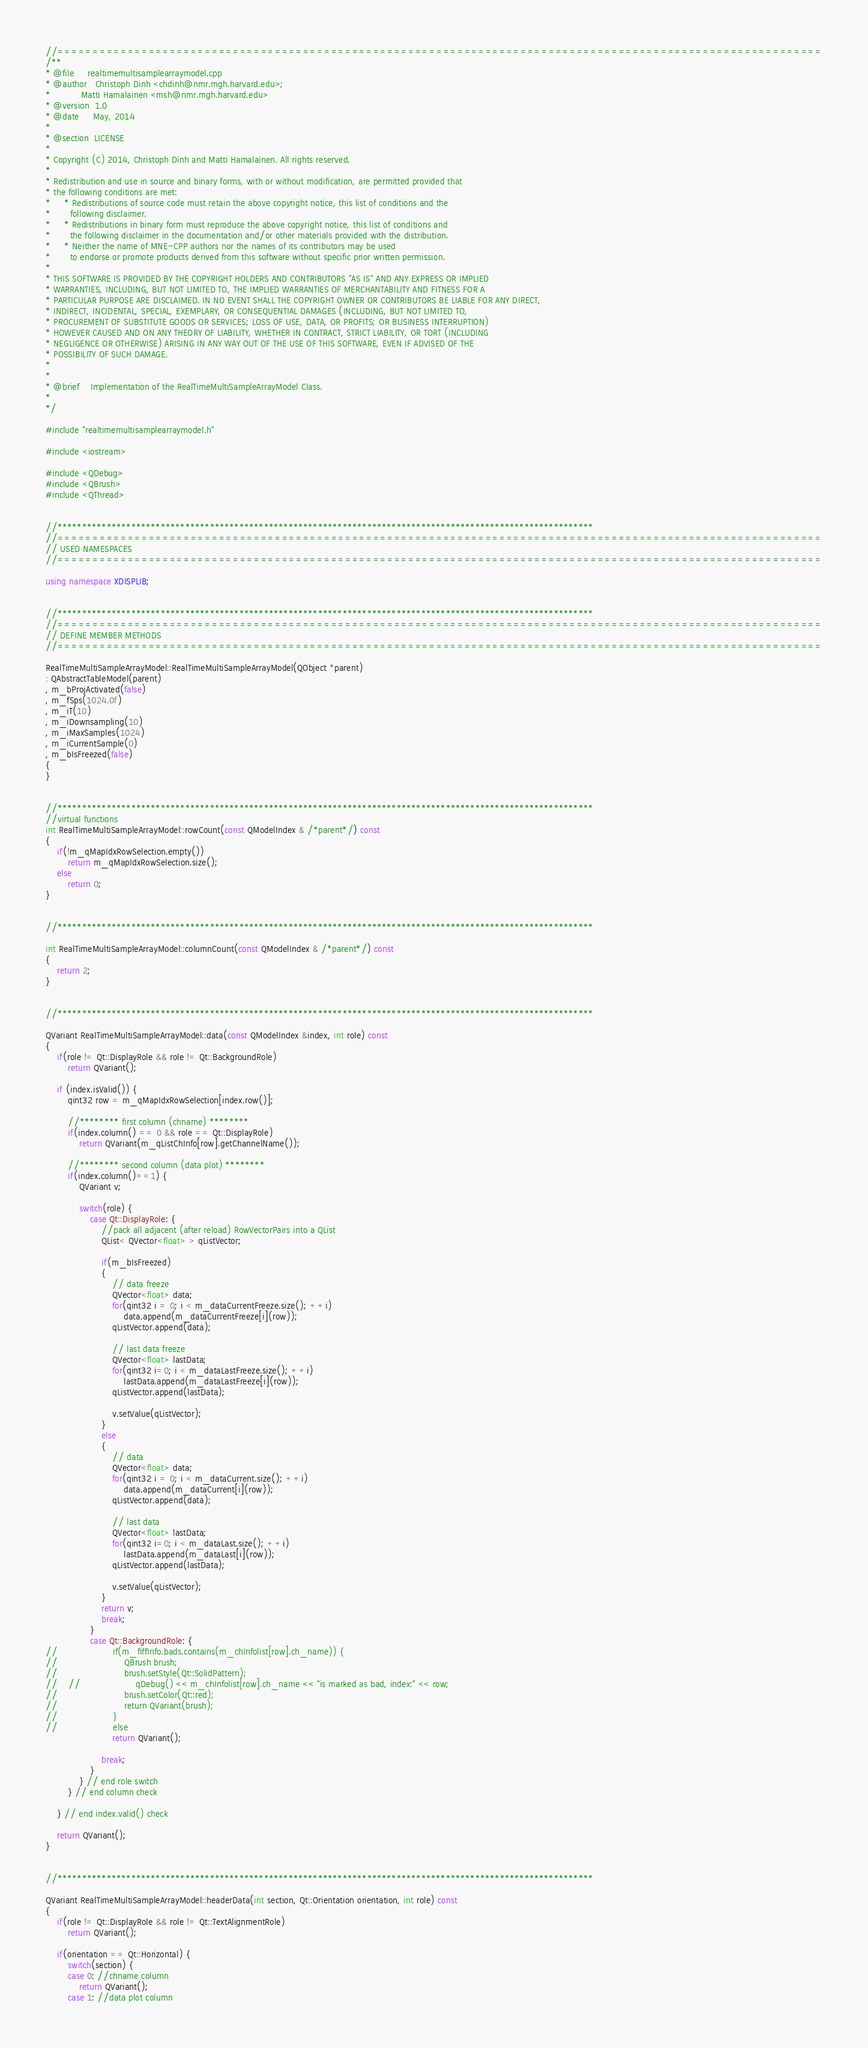Convert code to text. <code><loc_0><loc_0><loc_500><loc_500><_C++_>//=============================================================================================================
/**
* @file     realtimemultisamplearraymodel.cpp
* @author   Christoph Dinh <chdinh@nmr.mgh.harvard.edu>;
*           Matti Hamalainen <msh@nmr.mgh.harvard.edu>
* @version  1.0
* @date     May, 2014
*
* @section  LICENSE
*
* Copyright (C) 2014, Christoph Dinh and Matti Hamalainen. All rights reserved.
*
* Redistribution and use in source and binary forms, with or without modification, are permitted provided that
* the following conditions are met:
*     * Redistributions of source code must retain the above copyright notice, this list of conditions and the
*       following disclaimer.
*     * Redistributions in binary form must reproduce the above copyright notice, this list of conditions and
*       the following disclaimer in the documentation and/or other materials provided with the distribution.
*     * Neither the name of MNE-CPP authors nor the names of its contributors may be used
*       to endorse or promote products derived from this software without specific prior written permission.
*
* THIS SOFTWARE IS PROVIDED BY THE COPYRIGHT HOLDERS AND CONTRIBUTORS "AS IS" AND ANY EXPRESS OR IMPLIED
* WARRANTIES, INCLUDING, BUT NOT LIMITED TO, THE IMPLIED WARRANTIES OF MERCHANTABILITY AND FITNESS FOR A
* PARTICULAR PURPOSE ARE DISCLAIMED. IN NO EVENT SHALL THE COPYRIGHT OWNER OR CONTRIBUTORS BE LIABLE FOR ANY DIRECT,
* INDIRECT, INCIDENTAL, SPECIAL, EXEMPLARY, OR CONSEQUENTIAL DAMAGES (INCLUDING, BUT NOT LIMITED TO,
* PROCUREMENT OF SUBSTITUTE GOODS OR SERVICES; LOSS OF USE, DATA, OR PROFITS; OR BUSINESS INTERRUPTION)
* HOWEVER CAUSED AND ON ANY THEORY OF LIABILITY, WHETHER IN CONTRACT, STRICT LIABILITY, OR TORT (INCLUDING
* NEGLIGENCE OR OTHERWISE) ARISING IN ANY WAY OUT OF THE USE OF THIS SOFTWARE, EVEN IF ADVISED OF THE
* POSSIBILITY OF SUCH DAMAGE.
*
*
* @brief    Implementation of the RealTimeMultiSampleArrayModel Class.
*
*/

#include "realtimemultisamplearraymodel.h"

#include <iostream>

#include <QDebug>
#include <QBrush>
#include <QThread>


//*************************************************************************************************************
//=============================================================================================================
// USED NAMESPACES
//=============================================================================================================

using namespace XDISPLIB;


//*************************************************************************************************************
//=============================================================================================================
// DEFINE MEMBER METHODS
//=============================================================================================================

RealTimeMultiSampleArrayModel::RealTimeMultiSampleArrayModel(QObject *parent)
: QAbstractTableModel(parent)
, m_bProjActivated(false)
, m_fSps(1024.0f)
, m_iT(10)
, m_iDownsampling(10)
, m_iMaxSamples(1024)
, m_iCurrentSample(0)
, m_bIsFreezed(false)
{
}


//*************************************************************************************************************
//virtual functions
int RealTimeMultiSampleArrayModel::rowCount(const QModelIndex & /*parent*/) const
{
    if(!m_qMapIdxRowSelection.empty())
        return m_qMapIdxRowSelection.size();
    else
        return 0;
}


//*************************************************************************************************************

int RealTimeMultiSampleArrayModel::columnCount(const QModelIndex & /*parent*/) const
{
    return 2;
}


//*************************************************************************************************************

QVariant RealTimeMultiSampleArrayModel::data(const QModelIndex &index, int role) const
{
    if(role != Qt::DisplayRole && role != Qt::BackgroundRole)
        return QVariant();

    if (index.isValid()) {
        qint32 row = m_qMapIdxRowSelection[index.row()];

        //******** first column (chname) ********
        if(index.column() == 0 && role == Qt::DisplayRole)
            return QVariant(m_qListChInfo[row].getChannelName());

        //******** second column (data plot) ********
        if(index.column()==1) {
            QVariant v;

            switch(role) {
                case Qt::DisplayRole: {
                    //pack all adjacent (after reload) RowVectorPairs into a QList
                    QList< QVector<float> > qListVector;

                    if(m_bIsFreezed)
                    {
                        // data freeze
                        QVector<float> data;
                        for(qint32 i = 0; i < m_dataCurrentFreeze.size(); ++i)
                            data.append(m_dataCurrentFreeze[i](row));
                        qListVector.append(data);

                        // last data freeze
                        QVector<float> lastData;
                        for(qint32 i=0; i < m_dataLastFreeze.size(); ++i)
                            lastData.append(m_dataLastFreeze[i](row));
                        qListVector.append(lastData);

                        v.setValue(qListVector);
                    }
                    else
                    {
                        // data
                        QVector<float> data;
                        for(qint32 i = 0; i < m_dataCurrent.size(); ++i)
                            data.append(m_dataCurrent[i](row));
                        qListVector.append(data);

                        // last data
                        QVector<float> lastData;
                        for(qint32 i=0; i < m_dataLast.size(); ++i)
                            lastData.append(m_dataLast[i](row));
                        qListVector.append(lastData);

                        v.setValue(qListVector);
                    }
                    return v;
                    break;
                }
                case Qt::BackgroundRole: {
//                    if(m_fiffInfo.bads.contains(m_chInfolist[row].ch_name)) {
//                        QBrush brush;
//                        brush.setStyle(Qt::SolidPattern);
//    //                    qDebug() << m_chInfolist[row].ch_name << "is marked as bad, index:" << row;
//                        brush.setColor(Qt::red);
//                        return QVariant(brush);
//                    }
//                    else
                        return QVariant();

                    break;
                }
            } // end role switch
        } // end column check

    } // end index.valid() check

    return QVariant();
}


//*************************************************************************************************************

QVariant RealTimeMultiSampleArrayModel::headerData(int section, Qt::Orientation orientation, int role) const
{
    if(role != Qt::DisplayRole && role != Qt::TextAlignmentRole)
        return QVariant();

    if(orientation == Qt::Horizontal) {
        switch(section) {
        case 0: //chname column
            return QVariant();
        case 1: //data plot column</code> 